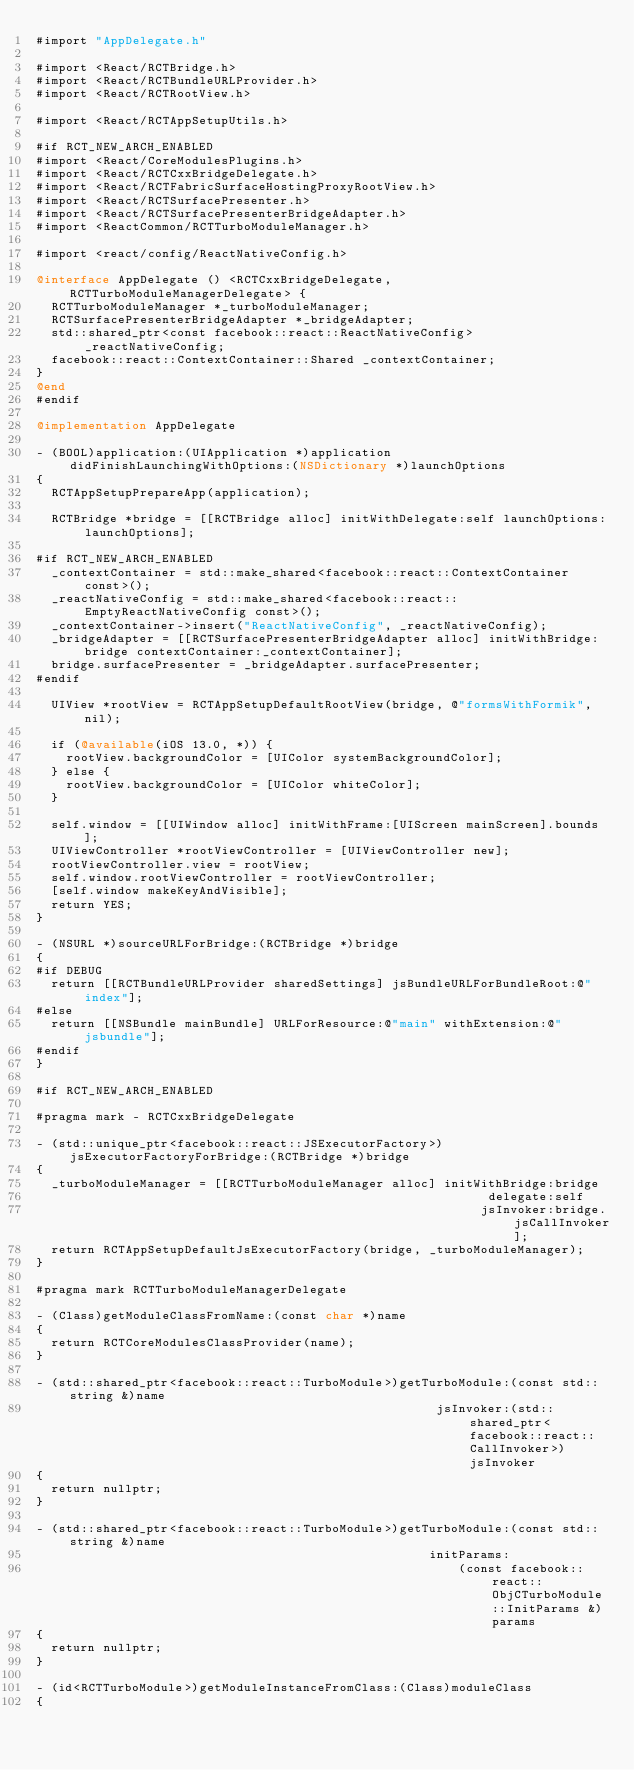<code> <loc_0><loc_0><loc_500><loc_500><_ObjectiveC_>#import "AppDelegate.h"

#import <React/RCTBridge.h>
#import <React/RCTBundleURLProvider.h>
#import <React/RCTRootView.h>

#import <React/RCTAppSetupUtils.h>

#if RCT_NEW_ARCH_ENABLED
#import <React/CoreModulesPlugins.h>
#import <React/RCTCxxBridgeDelegate.h>
#import <React/RCTFabricSurfaceHostingProxyRootView.h>
#import <React/RCTSurfacePresenter.h>
#import <React/RCTSurfacePresenterBridgeAdapter.h>
#import <ReactCommon/RCTTurboModuleManager.h>

#import <react/config/ReactNativeConfig.h>

@interface AppDelegate () <RCTCxxBridgeDelegate, RCTTurboModuleManagerDelegate> {
  RCTTurboModuleManager *_turboModuleManager;
  RCTSurfacePresenterBridgeAdapter *_bridgeAdapter;
  std::shared_ptr<const facebook::react::ReactNativeConfig> _reactNativeConfig;
  facebook::react::ContextContainer::Shared _contextContainer;
}
@end
#endif

@implementation AppDelegate

- (BOOL)application:(UIApplication *)application didFinishLaunchingWithOptions:(NSDictionary *)launchOptions
{
  RCTAppSetupPrepareApp(application);

  RCTBridge *bridge = [[RCTBridge alloc] initWithDelegate:self launchOptions:launchOptions];

#if RCT_NEW_ARCH_ENABLED
  _contextContainer = std::make_shared<facebook::react::ContextContainer const>();
  _reactNativeConfig = std::make_shared<facebook::react::EmptyReactNativeConfig const>();
  _contextContainer->insert("ReactNativeConfig", _reactNativeConfig);
  _bridgeAdapter = [[RCTSurfacePresenterBridgeAdapter alloc] initWithBridge:bridge contextContainer:_contextContainer];
  bridge.surfacePresenter = _bridgeAdapter.surfacePresenter;
#endif

  UIView *rootView = RCTAppSetupDefaultRootView(bridge, @"formsWithFormik", nil);

  if (@available(iOS 13.0, *)) {
    rootView.backgroundColor = [UIColor systemBackgroundColor];
  } else {
    rootView.backgroundColor = [UIColor whiteColor];
  }

  self.window = [[UIWindow alloc] initWithFrame:[UIScreen mainScreen].bounds];
  UIViewController *rootViewController = [UIViewController new];
  rootViewController.view = rootView;
  self.window.rootViewController = rootViewController;
  [self.window makeKeyAndVisible];
  return YES;
}

- (NSURL *)sourceURLForBridge:(RCTBridge *)bridge
{
#if DEBUG
  return [[RCTBundleURLProvider sharedSettings] jsBundleURLForBundleRoot:@"index"];
#else
  return [[NSBundle mainBundle] URLForResource:@"main" withExtension:@"jsbundle"];
#endif
}

#if RCT_NEW_ARCH_ENABLED

#pragma mark - RCTCxxBridgeDelegate

- (std::unique_ptr<facebook::react::JSExecutorFactory>)jsExecutorFactoryForBridge:(RCTBridge *)bridge
{
  _turboModuleManager = [[RCTTurboModuleManager alloc] initWithBridge:bridge
                                                             delegate:self
                                                            jsInvoker:bridge.jsCallInvoker];
  return RCTAppSetupDefaultJsExecutorFactory(bridge, _turboModuleManager);
}

#pragma mark RCTTurboModuleManagerDelegate

- (Class)getModuleClassFromName:(const char *)name
{
  return RCTCoreModulesClassProvider(name);
}

- (std::shared_ptr<facebook::react::TurboModule>)getTurboModule:(const std::string &)name
                                                      jsInvoker:(std::shared_ptr<facebook::react::CallInvoker>)jsInvoker
{
  return nullptr;
}

- (std::shared_ptr<facebook::react::TurboModule>)getTurboModule:(const std::string &)name
                                                     initParams:
                                                         (const facebook::react::ObjCTurboModule::InitParams &)params
{
  return nullptr;
}

- (id<RCTTurboModule>)getModuleInstanceFromClass:(Class)moduleClass
{</code> 